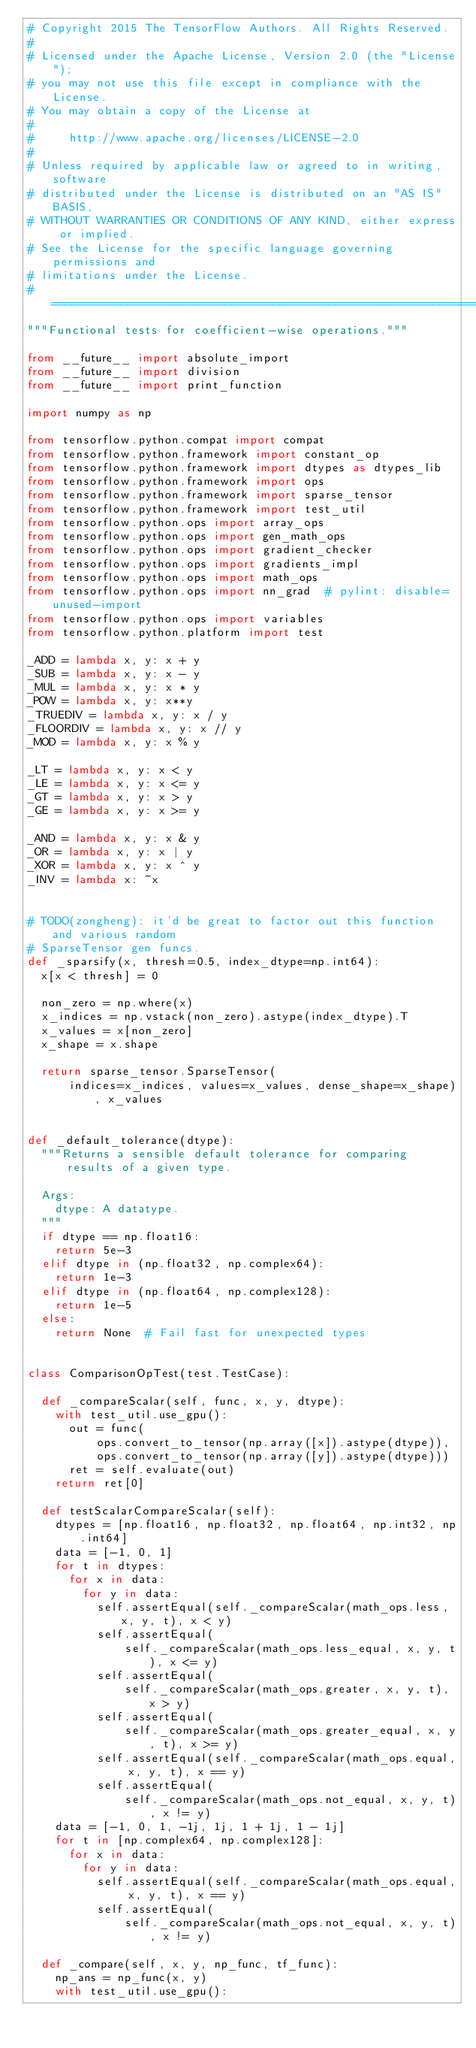Convert code to text. <code><loc_0><loc_0><loc_500><loc_500><_Python_># Copyright 2015 The TensorFlow Authors. All Rights Reserved.
#
# Licensed under the Apache License, Version 2.0 (the "License");
# you may not use this file except in compliance with the License.
# You may obtain a copy of the License at
#
#     http://www.apache.org/licenses/LICENSE-2.0
#
# Unless required by applicable law or agreed to in writing, software
# distributed under the License is distributed on an "AS IS" BASIS,
# WITHOUT WARRANTIES OR CONDITIONS OF ANY KIND, either express or implied.
# See the License for the specific language governing permissions and
# limitations under the License.
# ==============================================================================
"""Functional tests for coefficient-wise operations."""

from __future__ import absolute_import
from __future__ import division
from __future__ import print_function

import numpy as np

from tensorflow.python.compat import compat
from tensorflow.python.framework import constant_op
from tensorflow.python.framework import dtypes as dtypes_lib
from tensorflow.python.framework import ops
from tensorflow.python.framework import sparse_tensor
from tensorflow.python.framework import test_util
from tensorflow.python.ops import array_ops
from tensorflow.python.ops import gen_math_ops
from tensorflow.python.ops import gradient_checker
from tensorflow.python.ops import gradients_impl
from tensorflow.python.ops import math_ops
from tensorflow.python.ops import nn_grad  # pylint: disable=unused-import
from tensorflow.python.ops import variables
from tensorflow.python.platform import test

_ADD = lambda x, y: x + y
_SUB = lambda x, y: x - y
_MUL = lambda x, y: x * y
_POW = lambda x, y: x**y
_TRUEDIV = lambda x, y: x / y
_FLOORDIV = lambda x, y: x // y
_MOD = lambda x, y: x % y

_LT = lambda x, y: x < y
_LE = lambda x, y: x <= y
_GT = lambda x, y: x > y
_GE = lambda x, y: x >= y

_AND = lambda x, y: x & y
_OR = lambda x, y: x | y
_XOR = lambda x, y: x ^ y
_INV = lambda x: ~x


# TODO(zongheng): it'd be great to factor out this function and various random
# SparseTensor gen funcs.
def _sparsify(x, thresh=0.5, index_dtype=np.int64):
  x[x < thresh] = 0

  non_zero = np.where(x)
  x_indices = np.vstack(non_zero).astype(index_dtype).T
  x_values = x[non_zero]
  x_shape = x.shape

  return sparse_tensor.SparseTensor(
      indices=x_indices, values=x_values, dense_shape=x_shape), x_values


def _default_tolerance(dtype):
  """Returns a sensible default tolerance for comparing results of a given type.

  Args:
    dtype: A datatype.
  """
  if dtype == np.float16:
    return 5e-3
  elif dtype in (np.float32, np.complex64):
    return 1e-3
  elif dtype in (np.float64, np.complex128):
    return 1e-5
  else:
    return None  # Fail fast for unexpected types


class ComparisonOpTest(test.TestCase):

  def _compareScalar(self, func, x, y, dtype):
    with test_util.use_gpu():
      out = func(
          ops.convert_to_tensor(np.array([x]).astype(dtype)),
          ops.convert_to_tensor(np.array([y]).astype(dtype)))
      ret = self.evaluate(out)
    return ret[0]

  def testScalarCompareScalar(self):
    dtypes = [np.float16, np.float32, np.float64, np.int32, np.int64]
    data = [-1, 0, 1]
    for t in dtypes:
      for x in data:
        for y in data:
          self.assertEqual(self._compareScalar(math_ops.less, x, y, t), x < y)
          self.assertEqual(
              self._compareScalar(math_ops.less_equal, x, y, t), x <= y)
          self.assertEqual(
              self._compareScalar(math_ops.greater, x, y, t), x > y)
          self.assertEqual(
              self._compareScalar(math_ops.greater_equal, x, y, t), x >= y)
          self.assertEqual(self._compareScalar(math_ops.equal, x, y, t), x == y)
          self.assertEqual(
              self._compareScalar(math_ops.not_equal, x, y, t), x != y)
    data = [-1, 0, 1, -1j, 1j, 1 + 1j, 1 - 1j]
    for t in [np.complex64, np.complex128]:
      for x in data:
        for y in data:
          self.assertEqual(self._compareScalar(math_ops.equal, x, y, t), x == y)
          self.assertEqual(
              self._compareScalar(math_ops.not_equal, x, y, t), x != y)

  def _compare(self, x, y, np_func, tf_func):
    np_ans = np_func(x, y)
    with test_util.use_gpu():</code> 